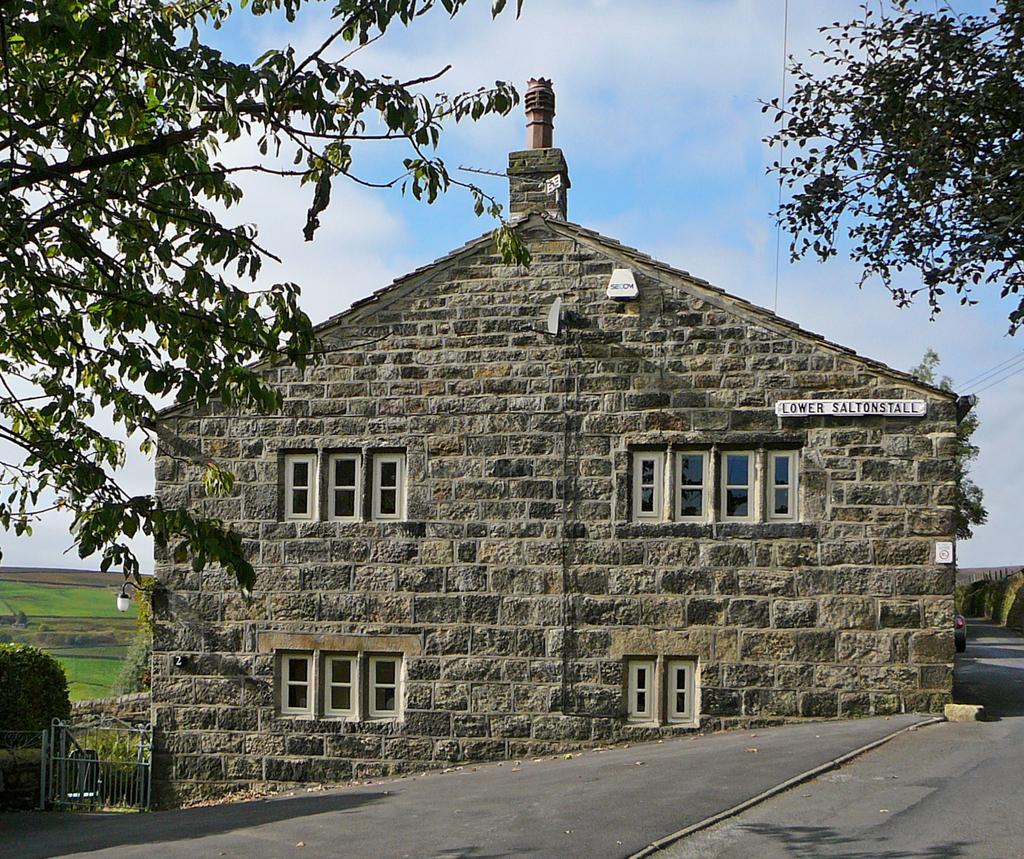Please provide a concise description of this image. In this image, we can see a house with some text written. We can see the ground. We can also see the fence. We can see some grass, plants. There are a few trees. We can see the sky with clouds. 